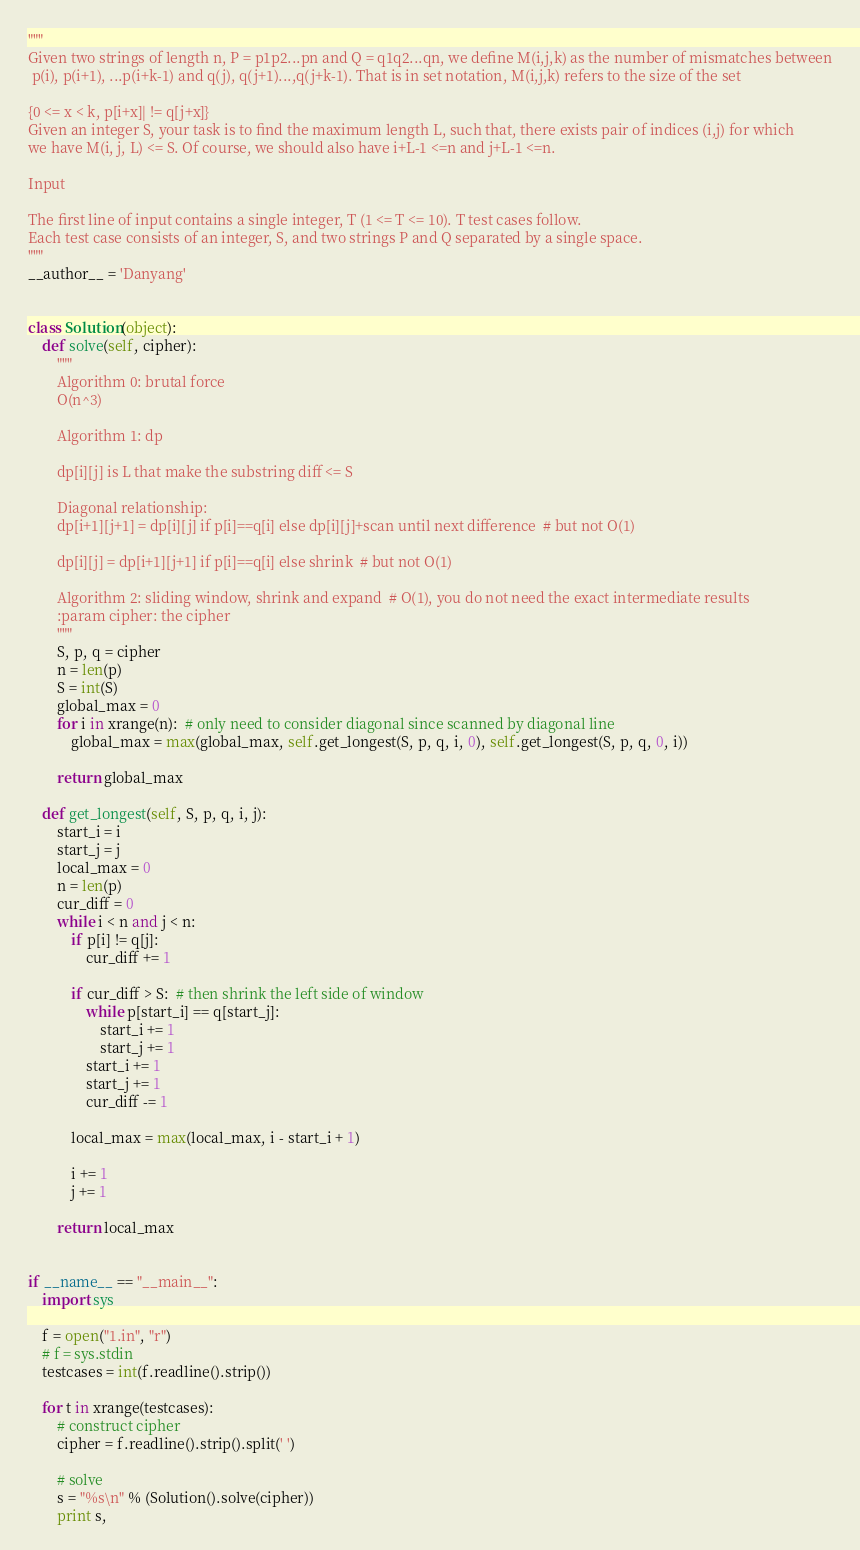Convert code to text. <code><loc_0><loc_0><loc_500><loc_500><_Python_>"""
Given two strings of length n, P = p1p2...pn and Q = q1q2...qn, we define M(i,j,k) as the number of mismatches between
 p(i), p(i+1), ...p(i+k-1) and q(j), q(j+1)...,q(j+k-1). That is in set notation, M(i,j,k) refers to the size of the set

{0 <= x < k, p[i+x]| != q[j+x]}
Given an integer S, your task is to find the maximum length L, such that, there exists pair of indices (i,j) for which
we have M(i, j, L) <= S. Of course, we should also have i+L-1 <=n and j+L-1 <=n.

Input

The first line of input contains a single integer, T (1 <= T <= 10). T test cases follow.
Each test case consists of an integer, S, and two strings P and Q separated by a single space.
"""
__author__ = 'Danyang'


class Solution(object):
    def solve(self, cipher):
        """
        Algorithm 0: brutal force
        O(n^3)

        Algorithm 1: dp

        dp[i][j] is L that make the substring diff <= S

        Diagonal relationship:
        dp[i+1][j+1] = dp[i][j] if p[i]==q[i] else dp[i][j]+scan until next difference  # but not O(1)

        dp[i][j] = dp[i+1][j+1] if p[i]==q[i] else shrink  # but not O(1)

        Algorithm 2: sliding window, shrink and expand  # O(1), you do not need the exact intermediate results
        :param cipher: the cipher
        """
        S, p, q = cipher
        n = len(p)
        S = int(S)
        global_max = 0
        for i in xrange(n):  # only need to consider diagonal since scanned by diagonal line
            global_max = max(global_max, self.get_longest(S, p, q, i, 0), self.get_longest(S, p, q, 0, i))

        return global_max

    def get_longest(self, S, p, q, i, j):
        start_i = i
        start_j = j
        local_max = 0
        n = len(p)
        cur_diff = 0
        while i < n and j < n:
            if p[i] != q[j]:
                cur_diff += 1

            if cur_diff > S:  # then shrink the left side of window
                while p[start_i] == q[start_j]:
                    start_i += 1
                    start_j += 1
                start_i += 1
                start_j += 1
                cur_diff -= 1

            local_max = max(local_max, i - start_i + 1)

            i += 1
            j += 1

        return local_max


if __name__ == "__main__":
    import sys

    f = open("1.in", "r")
    # f = sys.stdin
    testcases = int(f.readline().strip())

    for t in xrange(testcases):
        # construct cipher
        cipher = f.readline().strip().split(' ')

        # solve
        s = "%s\n" % (Solution().solve(cipher))
        print s,
</code> 